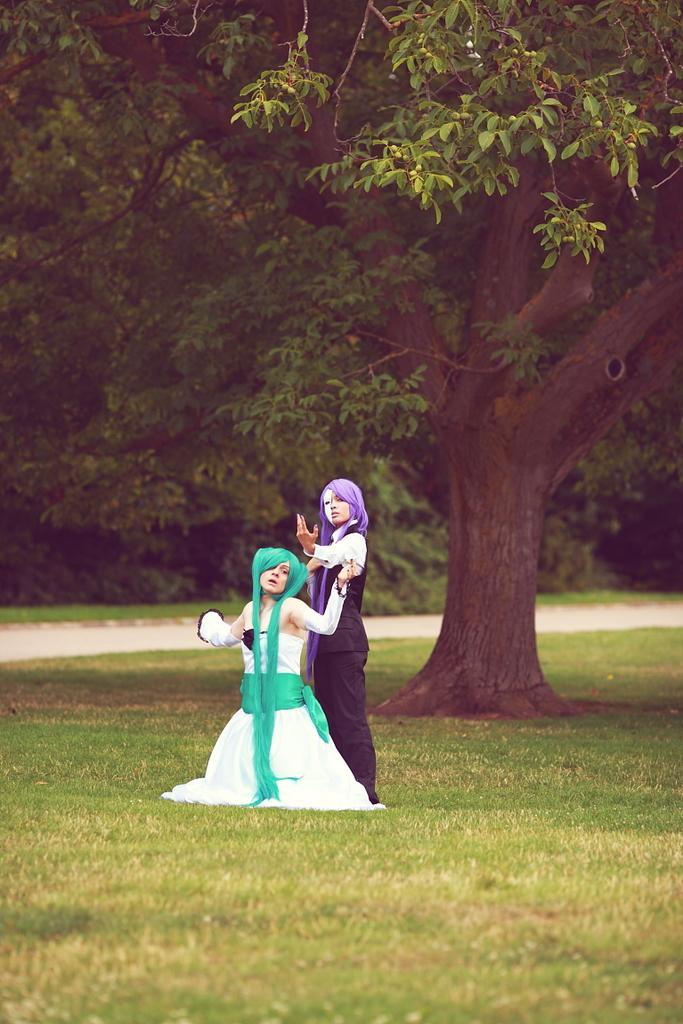Describe this image in one or two sentences. In this picture there are two persons with different costumes. At the back there are trees. At the bottom there is grass and there is a road. 